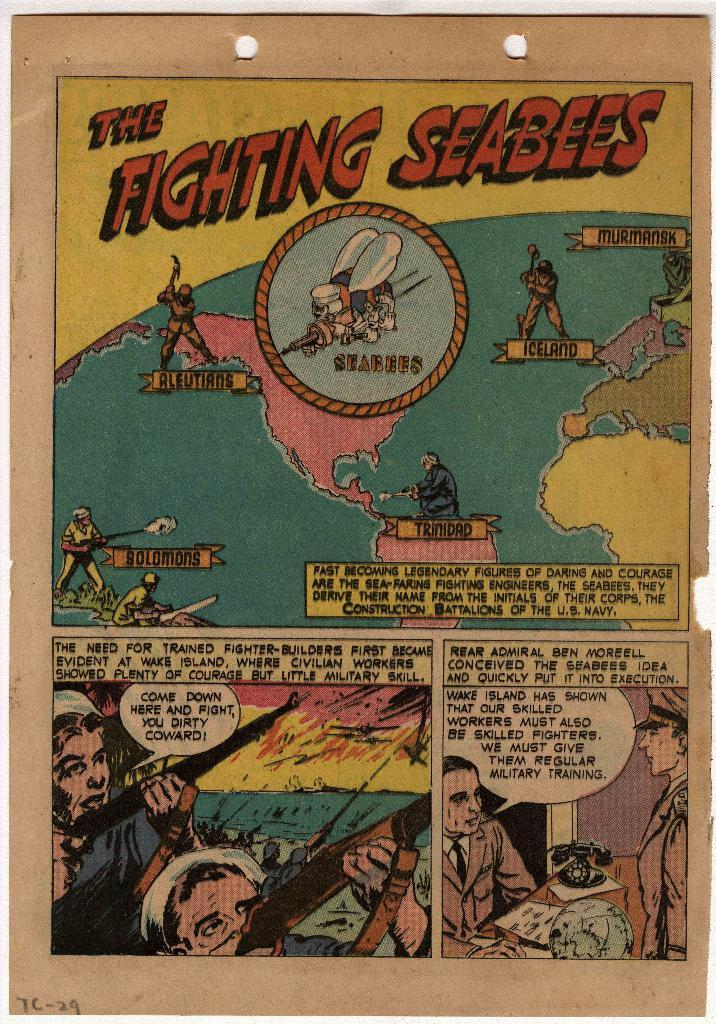<image>
Offer a succinct explanation of the picture presented. a comic that is called The Fighting Seabees 